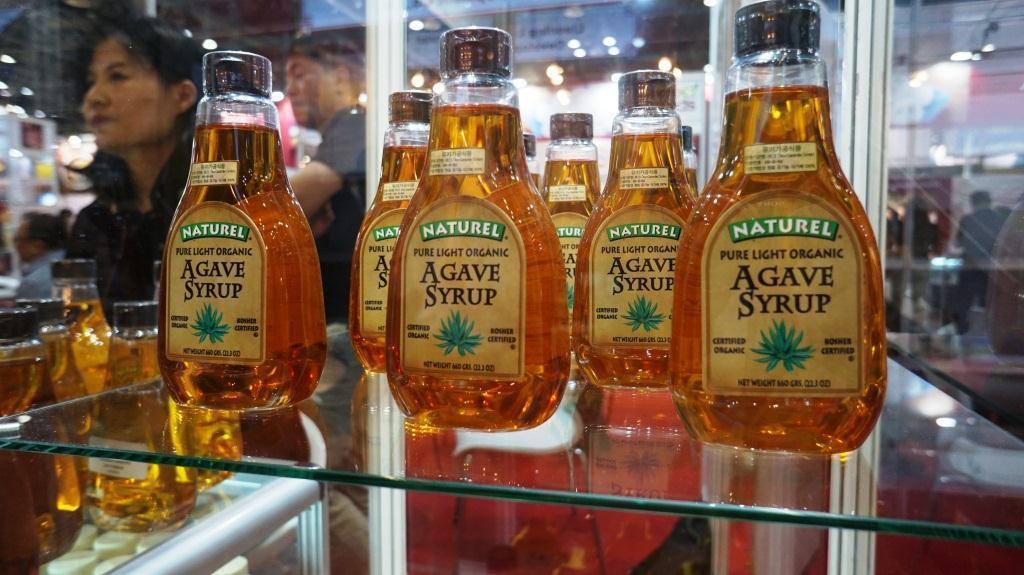Please provide a concise description of this image. in this picture there are bottles present on the shelf there is woman standing near the bottle ,there was a person who is standing a bit away from the woman,on the bottle we can see a label and text on it. 